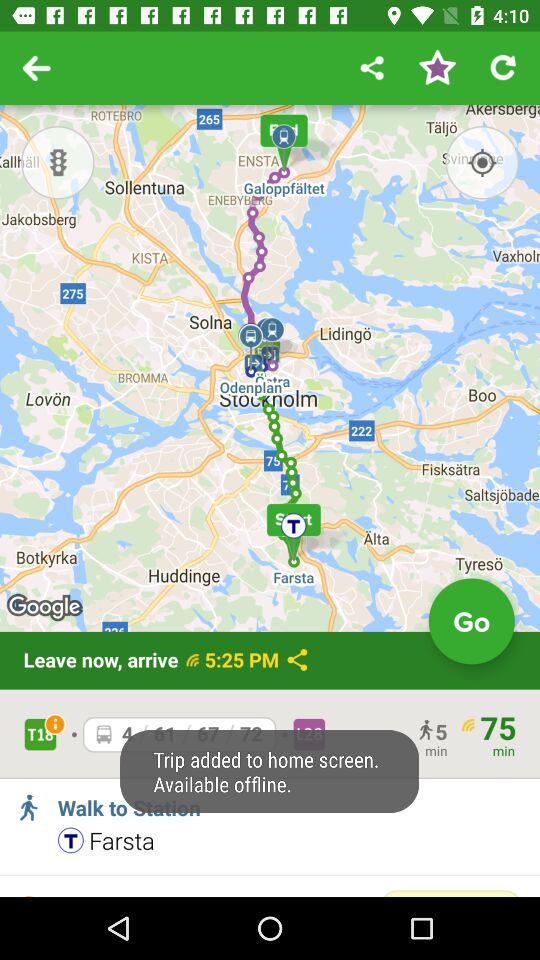What is the selected station? The selected station is Farsta. 